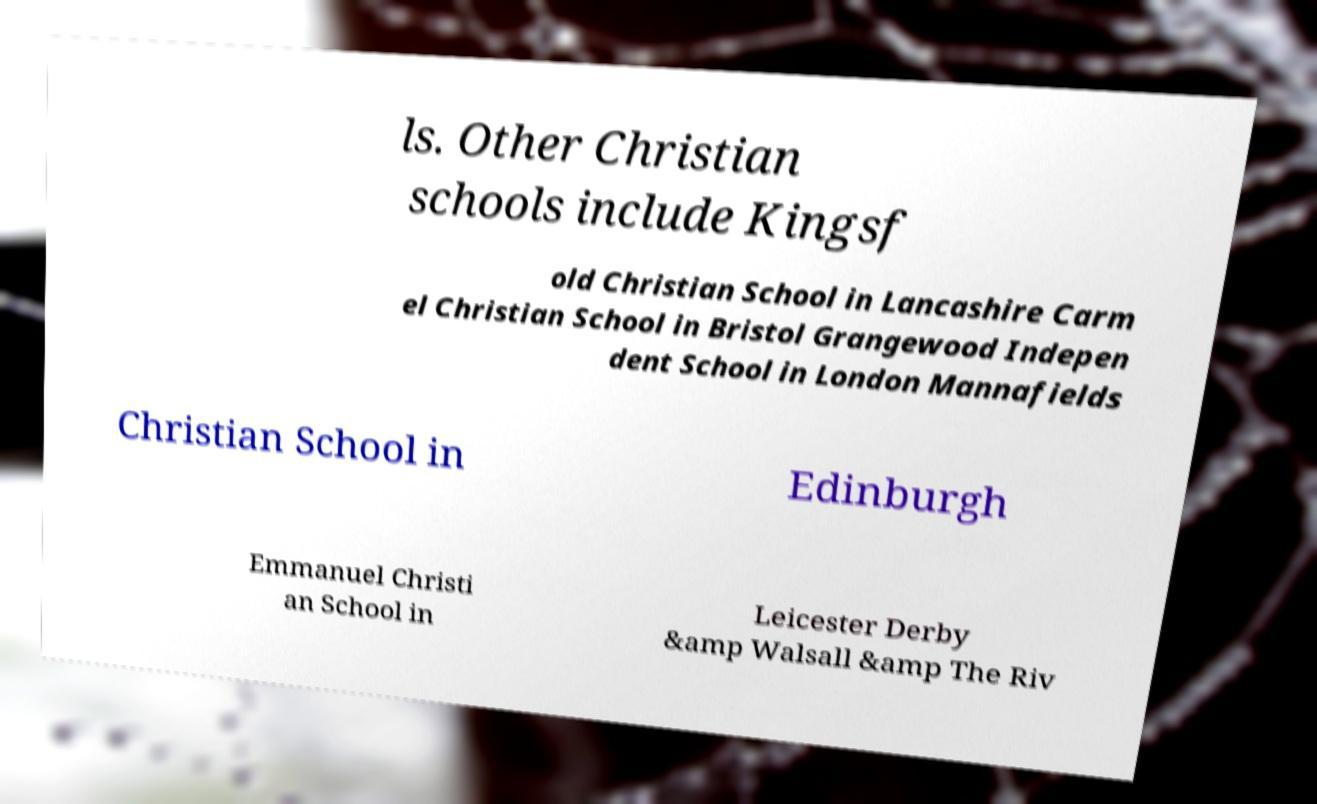I need the written content from this picture converted into text. Can you do that? ls. Other Christian schools include Kingsf old Christian School in Lancashire Carm el Christian School in Bristol Grangewood Indepen dent School in London Mannafields Christian School in Edinburgh Emmanuel Christi an School in Leicester Derby &amp Walsall &amp The Riv 